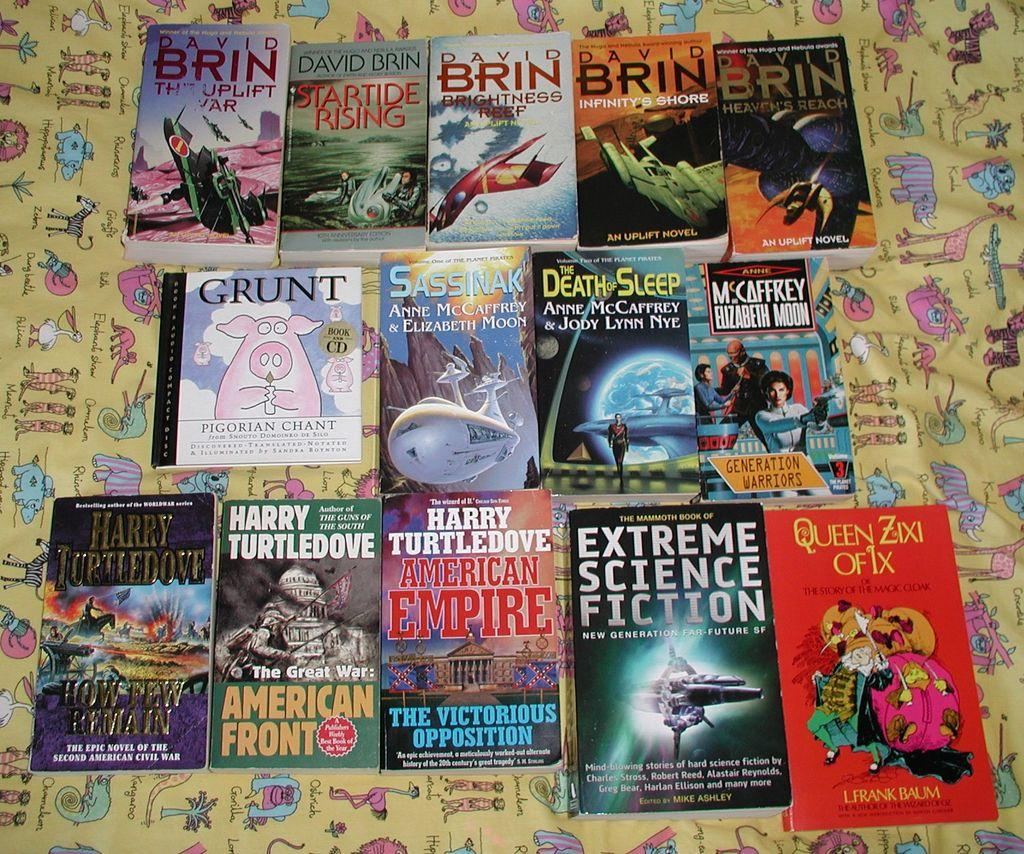<image>
Relay a brief, clear account of the picture shown. Books on a blanket including Extreme Science Fiction. 